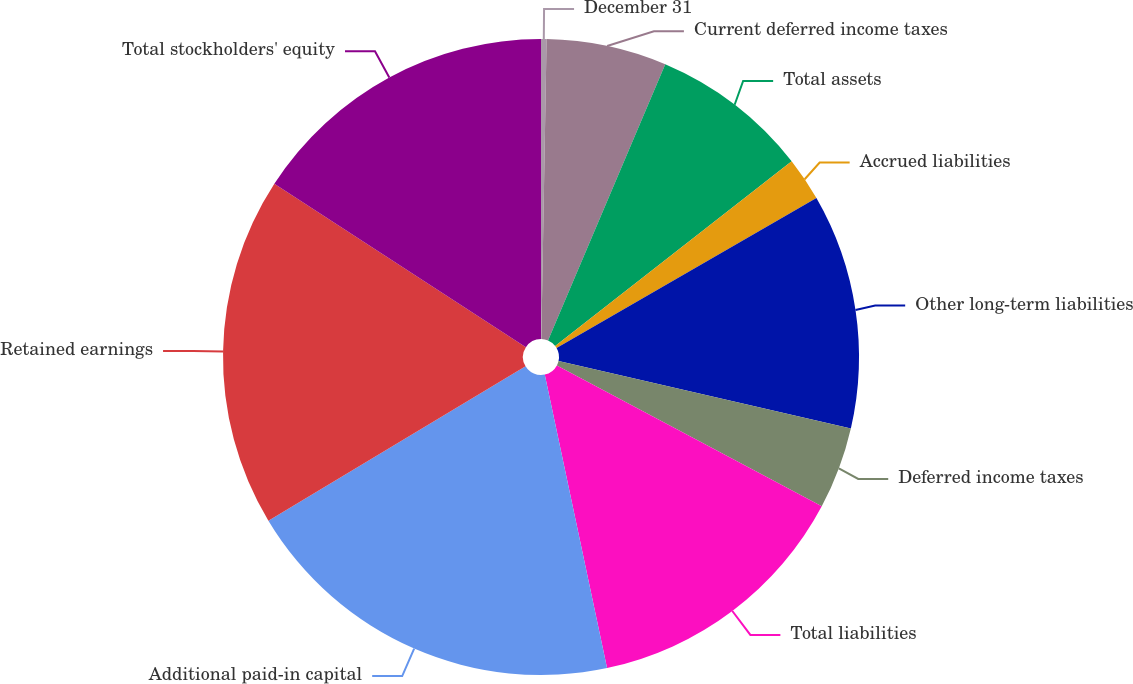Convert chart. <chart><loc_0><loc_0><loc_500><loc_500><pie_chart><fcel>December 31<fcel>Current deferred income taxes<fcel>Total assets<fcel>Accrued liabilities<fcel>Other long-term liabilities<fcel>Deferred income taxes<fcel>Total liabilities<fcel>Additional paid-in capital<fcel>Retained earnings<fcel>Total stockholders' equity<nl><fcel>0.28%<fcel>6.11%<fcel>8.06%<fcel>2.22%<fcel>11.94%<fcel>4.17%<fcel>13.89%<fcel>19.72%<fcel>17.78%<fcel>15.83%<nl></chart> 